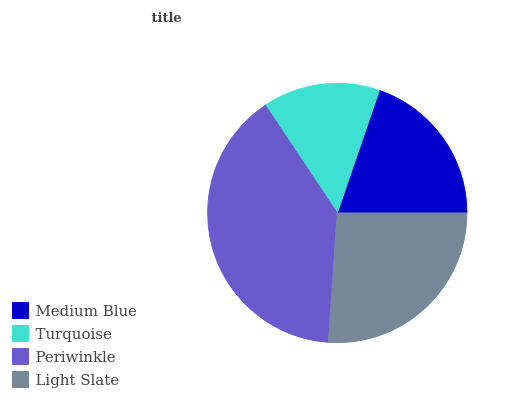Is Turquoise the minimum?
Answer yes or no. Yes. Is Periwinkle the maximum?
Answer yes or no. Yes. Is Periwinkle the minimum?
Answer yes or no. No. Is Turquoise the maximum?
Answer yes or no. No. Is Periwinkle greater than Turquoise?
Answer yes or no. Yes. Is Turquoise less than Periwinkle?
Answer yes or no. Yes. Is Turquoise greater than Periwinkle?
Answer yes or no. No. Is Periwinkle less than Turquoise?
Answer yes or no. No. Is Light Slate the high median?
Answer yes or no. Yes. Is Medium Blue the low median?
Answer yes or no. Yes. Is Medium Blue the high median?
Answer yes or no. No. Is Turquoise the low median?
Answer yes or no. No. 